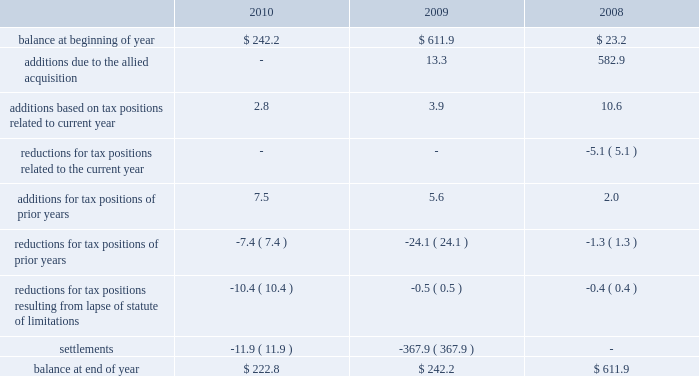Approximately $ 32 million of federal tax payments were deferred and paid in 2009 as a result of the allied acquisition .
The table summarizes the activity in our gross unrecognized tax benefits for the years ended december 31: .
New accounting guidance for business combinations became effective for our 2009 financial statements .
This new guidance changed the treatment of acquired uncertain tax liabilities .
Under previous guidance , changes in acquired uncertain tax liabilities were recognized through goodwill .
Under the new guidance , subsequent changes in acquired unrecognized tax liabilities are recognized through the income tax provision .
As of december 31 , 2010 , $ 206.5 million of the $ 222.8 million of unrecognized tax benefits related to tax positions taken by allied prior to the 2008 acquisition .
Included in the balance at december 31 , 2010 and 2009 are approximately $ 209.1 million and $ 217.6 million of unrecognized tax benefits ( net of the federal benefit on state issues ) that , if recognized , would affect the effective income tax rate in future periods .
During 2010 , the irs concluded its examination of our 2005 and 2007 tax years .
The conclusion of this examination reduced our gross unrecognized tax benefits by approximately $ 1.9 million .
We also resolved various state matters during 2010 that , in the aggregate , reduced our gross unrecognized tax benefits by approximately $ 10.0 million .
During 2009 , we settled our outstanding tax dispute related to allied 2019s risk management companies ( see 2013 risk management companies ) with both the department of justice ( doj ) and the internal revenue service ( irs ) .
This settlement reduced our gross unrecognized tax benefits by approximately $ 299.6 million .
During 2009 , we also settled with the irs , through an accounting method change , our outstanding tax dispute related to intercompany insurance premiums paid to allied 2019s captive insurance company .
This settlement reduced our gross unrecognized tax benefits by approximately $ 62.6 million .
In addition to these federal matters , we also resolved various state matters that , in the aggregate , reduced our gross unrecognized tax benefits during 2009 by approximately $ 5.8 million .
We recognize interest and penalties as incurred within the provision for income taxes in our consolidated statements of income .
Related to the unrecognized tax benefits previously noted , we accrued interest of $ 19.2 million during 2010 and , in total as of december 31 , 2010 , have recognized a liability for penalties of $ 1.2 million and interest of $ 99.9 million .
During 2009 , we accrued interest of $ 24.5 million and , in total at december 31 , 2009 , had recognized a liability for penalties of $ 1.5 million and interest of $ 92.3 million .
During 2008 , we accrued penalties of $ 0.2 million and interest of $ 5.2 million and , in total at december 31 , 2008 , had recognized a liability for penalties of $ 88.1 million and interest of $ 180.0 million .
Republic services , inc .
Notes to consolidated financial statements , continued .
In 2009 what was the gross adjustment to the unrecognized tax benefits balance based on the federal and state settlements in millions? 
Rationale: the gross adjustment to gross adjustment to the unrecognized tax benefits balance based on the federal and state settlements in millions was 368 millions
Computations: (5.8 + (299.6 + 62.6))
Answer: 368.0. Approximately $ 32 million of federal tax payments were deferred and paid in 2009 as a result of the allied acquisition .
The table summarizes the activity in our gross unrecognized tax benefits for the years ended december 31: .
New accounting guidance for business combinations became effective for our 2009 financial statements .
This new guidance changed the treatment of acquired uncertain tax liabilities .
Under previous guidance , changes in acquired uncertain tax liabilities were recognized through goodwill .
Under the new guidance , subsequent changes in acquired unrecognized tax liabilities are recognized through the income tax provision .
As of december 31 , 2010 , $ 206.5 million of the $ 222.8 million of unrecognized tax benefits related to tax positions taken by allied prior to the 2008 acquisition .
Included in the balance at december 31 , 2010 and 2009 are approximately $ 209.1 million and $ 217.6 million of unrecognized tax benefits ( net of the federal benefit on state issues ) that , if recognized , would affect the effective income tax rate in future periods .
During 2010 , the irs concluded its examination of our 2005 and 2007 tax years .
The conclusion of this examination reduced our gross unrecognized tax benefits by approximately $ 1.9 million .
We also resolved various state matters during 2010 that , in the aggregate , reduced our gross unrecognized tax benefits by approximately $ 10.0 million .
During 2009 , we settled our outstanding tax dispute related to allied 2019s risk management companies ( see 2013 risk management companies ) with both the department of justice ( doj ) and the internal revenue service ( irs ) .
This settlement reduced our gross unrecognized tax benefits by approximately $ 299.6 million .
During 2009 , we also settled with the irs , through an accounting method change , our outstanding tax dispute related to intercompany insurance premiums paid to allied 2019s captive insurance company .
This settlement reduced our gross unrecognized tax benefits by approximately $ 62.6 million .
In addition to these federal matters , we also resolved various state matters that , in the aggregate , reduced our gross unrecognized tax benefits during 2009 by approximately $ 5.8 million .
We recognize interest and penalties as incurred within the provision for income taxes in our consolidated statements of income .
Related to the unrecognized tax benefits previously noted , we accrued interest of $ 19.2 million during 2010 and , in total as of december 31 , 2010 , have recognized a liability for penalties of $ 1.2 million and interest of $ 99.9 million .
During 2009 , we accrued interest of $ 24.5 million and , in total at december 31 , 2009 , had recognized a liability for penalties of $ 1.5 million and interest of $ 92.3 million .
During 2008 , we accrued penalties of $ 0.2 million and interest of $ 5.2 million and , in total at december 31 , 2008 , had recognized a liability for penalties of $ 88.1 million and interest of $ 180.0 million .
Republic services , inc .
Notes to consolidated financial statements , continued .
What was the percent of the decline in the gross unrecognized tax benefits from 2009 to 2010? 
Rationale: from 2009 to 2010 the gross unrecognized tax benefits balance decreased by 8%
Computations: ((222.8 - 242.2) / 242.2)
Answer: -0.0801. 